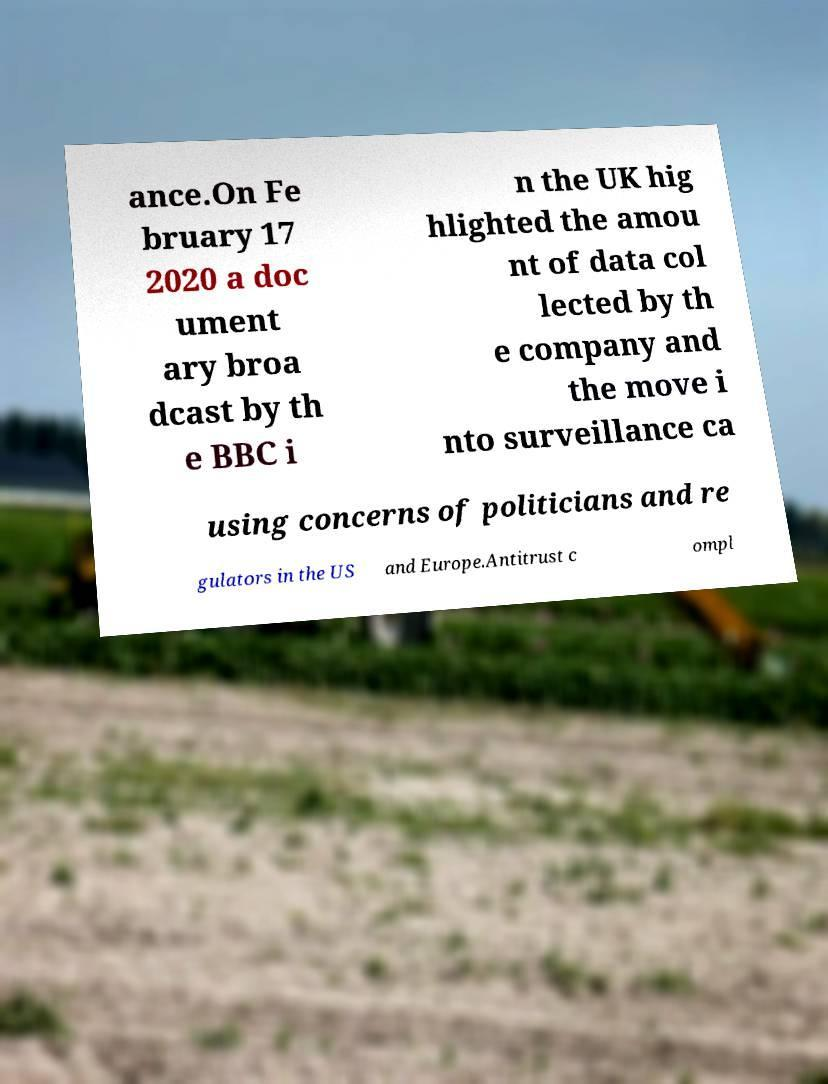There's text embedded in this image that I need extracted. Can you transcribe it verbatim? ance.On Fe bruary 17 2020 a doc ument ary broa dcast by th e BBC i n the UK hig hlighted the amou nt of data col lected by th e company and the move i nto surveillance ca using concerns of politicians and re gulators in the US and Europe.Antitrust c ompl 